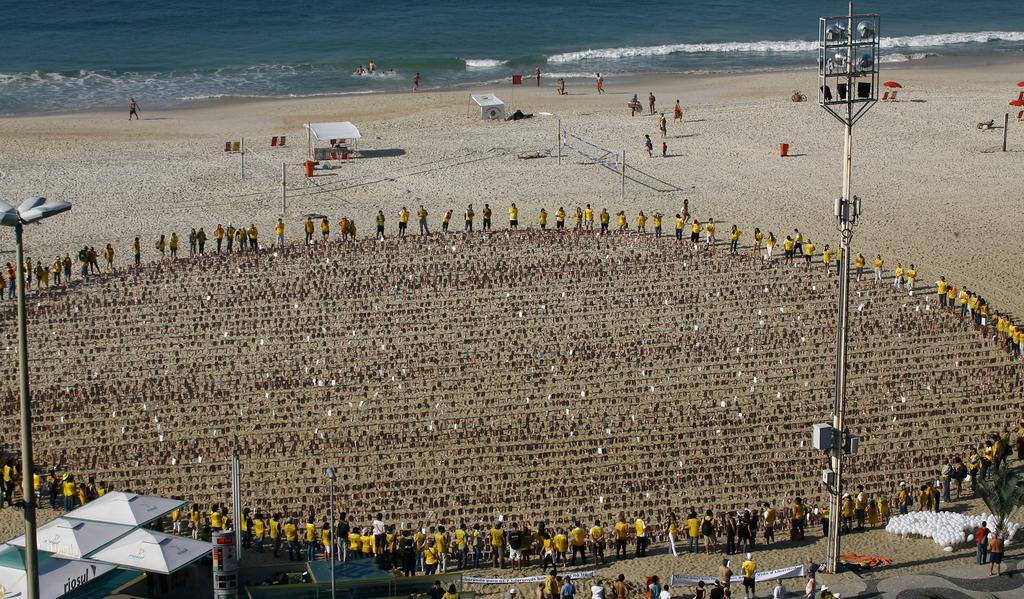Can you describe this image briefly? In this image, we can see a few people. We can see the ground covered with some objects. We can also see some poles, sheds, umbrellas. We can also see some water, a few white colored objects and banners. 